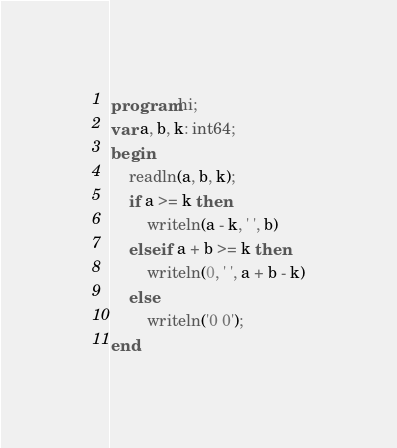<code> <loc_0><loc_0><loc_500><loc_500><_Pascal_>program hi;
var a, b, k: int64;
begin
    readln(a, b, k);
    if a >= k then 
        writeln(a - k, ' ', b)
    else if a + b >= k then 
        writeln(0, ' ', a + b - k)
    else 
        writeln('0 0');
end.</code> 